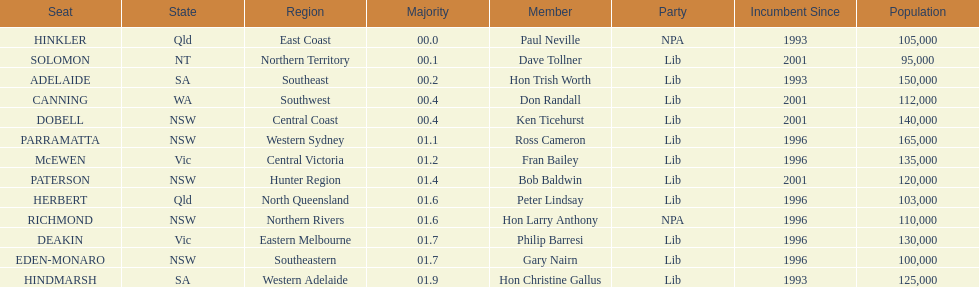What is the overall number of seats? 13. 